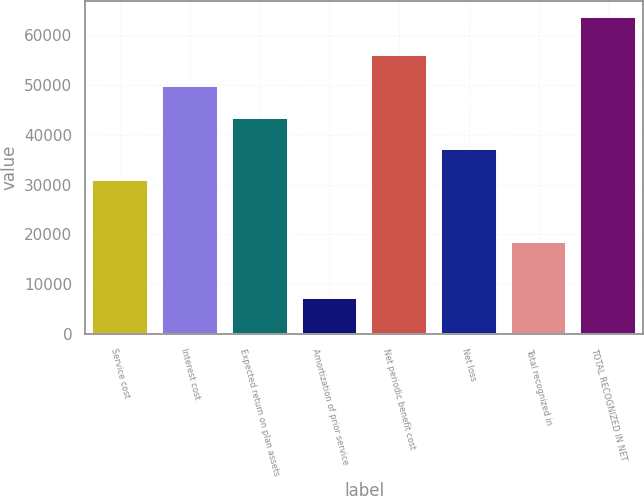<chart> <loc_0><loc_0><loc_500><loc_500><bar_chart><fcel>Service cost<fcel>Interest cost<fcel>Expected return on plan assets<fcel>Amortization of prior service<fcel>Net periodic benefit cost<fcel>Net loss<fcel>Total recognized in<fcel>TOTAL RECOGNIZED IN NET<nl><fcel>30945<fcel>49766.1<fcel>43492.4<fcel>7243.7<fcel>56039.8<fcel>37218.7<fcel>18435<fcel>63707<nl></chart> 